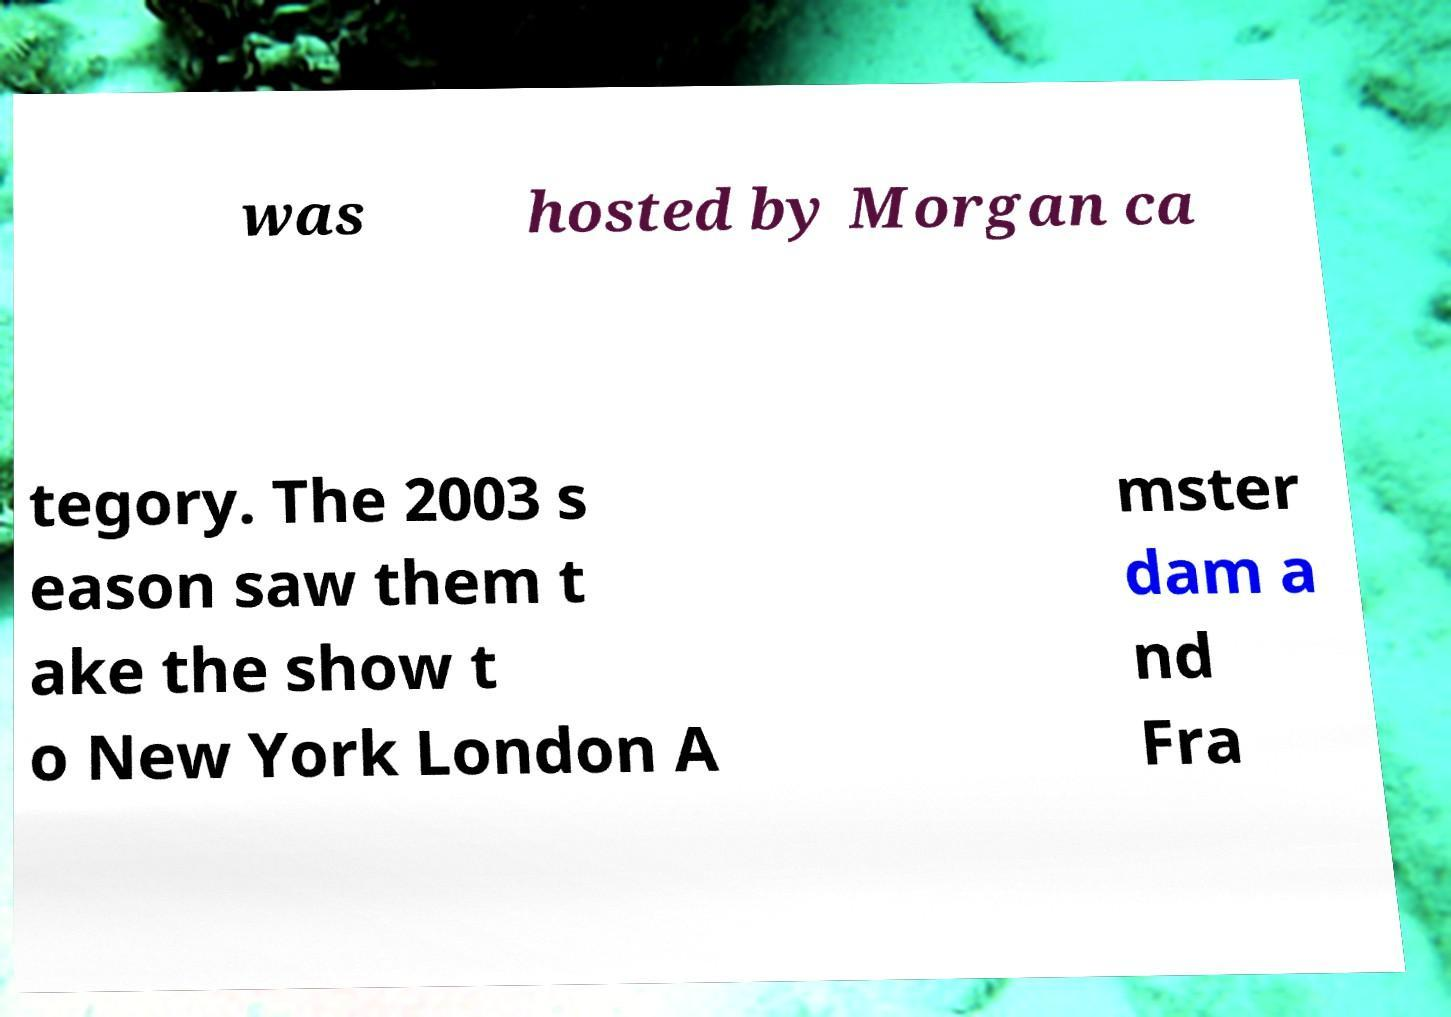Could you extract and type out the text from this image? was hosted by Morgan ca tegory. The 2003 s eason saw them t ake the show t o New York London A mster dam a nd Fra 